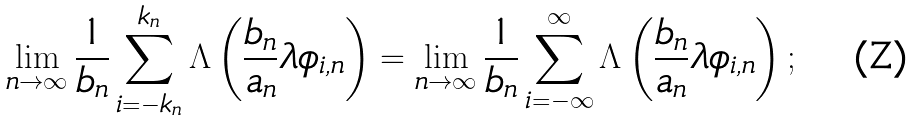Convert formula to latex. <formula><loc_0><loc_0><loc_500><loc_500>\lim _ { n \rightarrow \infty } \frac { 1 } { b _ { n } } \sum _ { i = - k _ { n } } ^ { k _ { n } } \Lambda \left ( \frac { b _ { n } } { a _ { n } } \lambda \phi _ { i , n } \right ) = \lim _ { n \rightarrow \infty } \frac { 1 } { b _ { n } } \sum _ { i = - \infty } ^ { \infty } \Lambda \left ( \frac { b _ { n } } { a _ { n } } \lambda \phi _ { i , n } \right ) ;</formula> 